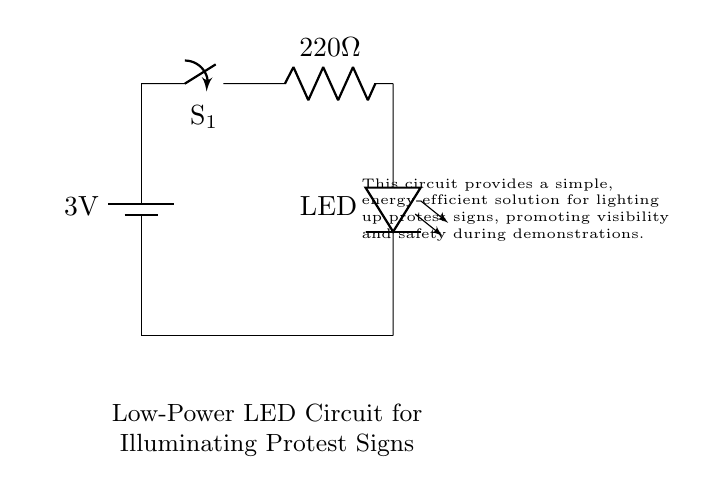What is the voltage of this circuit? The voltage of the circuit is 3 volts, indicated by the battery labeled with that potential difference across its terminals.
Answer: 3 volts What type of switch is used in this circuit? The circuit uses a simple switch, as represented by the symbol for a switch on the diagram, labeled as S1.
Answer: Switch What is the resistance value of the resistor in this circuit? The resistor is labeled with a value of 220 ohms, thus indicating its resistance measurement in the circuit.
Answer: 220 ohms How does the LED connect to the battery? The LED is connected in series to the battery, meaning all current from the battery passes through the LED as shown by the direct connection path.
Answer: In series What is the purpose of using a resistor in this circuit? The resistor limits the amount of current flowing through the LED to prevent it from overheating or burning out, ensuring safe operation.
Answer: Current limiting What happens when the switch S1 is closed? When switch S1 is closed, the circuit becomes complete which allows current to flow from the battery through the resistor and LED, illuminating the LED.
Answer: The LED lights up What kind of circuit configuration is used here? This circuit is a series configuration because all components are connected one after the other, creating a single path for current to flow.
Answer: Series configuration 